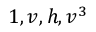<formula> <loc_0><loc_0><loc_500><loc_500>1 , v , h , v ^ { 3 }</formula> 